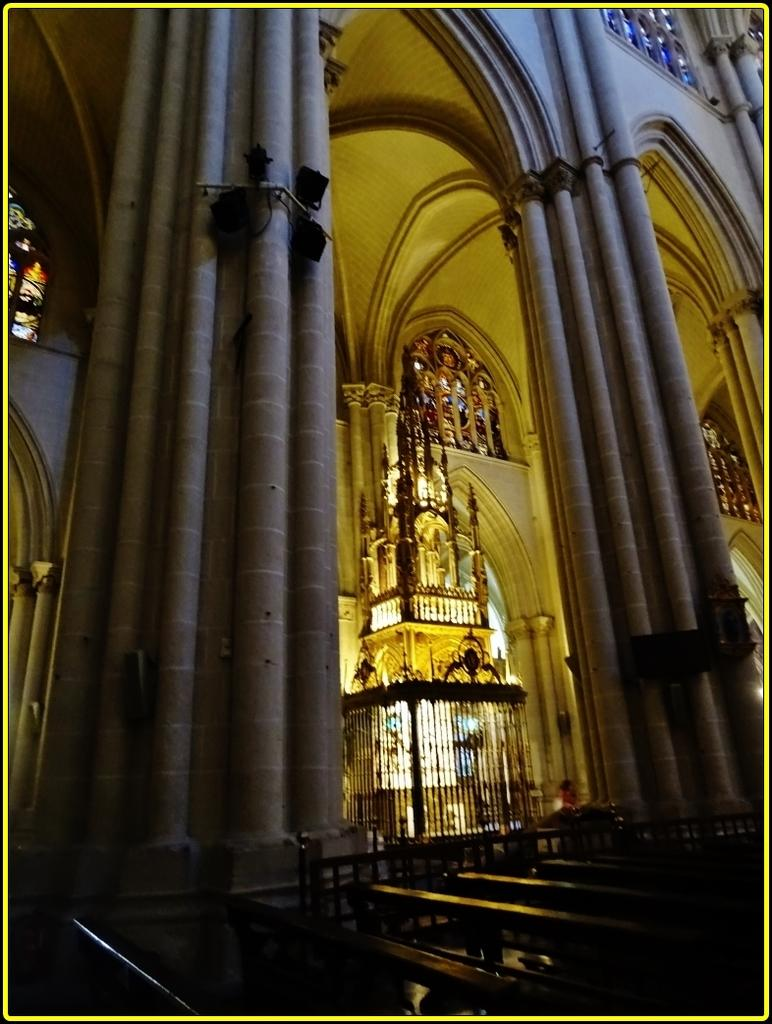Where was the image taken? The image was taken in a Cathedral. What type of seating is available at the bottom of the image? There are benches at the bottoms at the bottom of the image. What separates the seating area from the rest of the Cathedral? There is a railing at the bottom of the image. What can be seen in the background of the image? There are walls, pillars, and other architectural features in the background of the image. What type of activity is taking place in the image? There is no specific activity taking place in the image; it is a still image of a Cathedral interior. What view can be seen from the top of the pillars in the image? The image does not provide a view from the top of the pillars, as it is a still image taken from a ground-level perspective. 